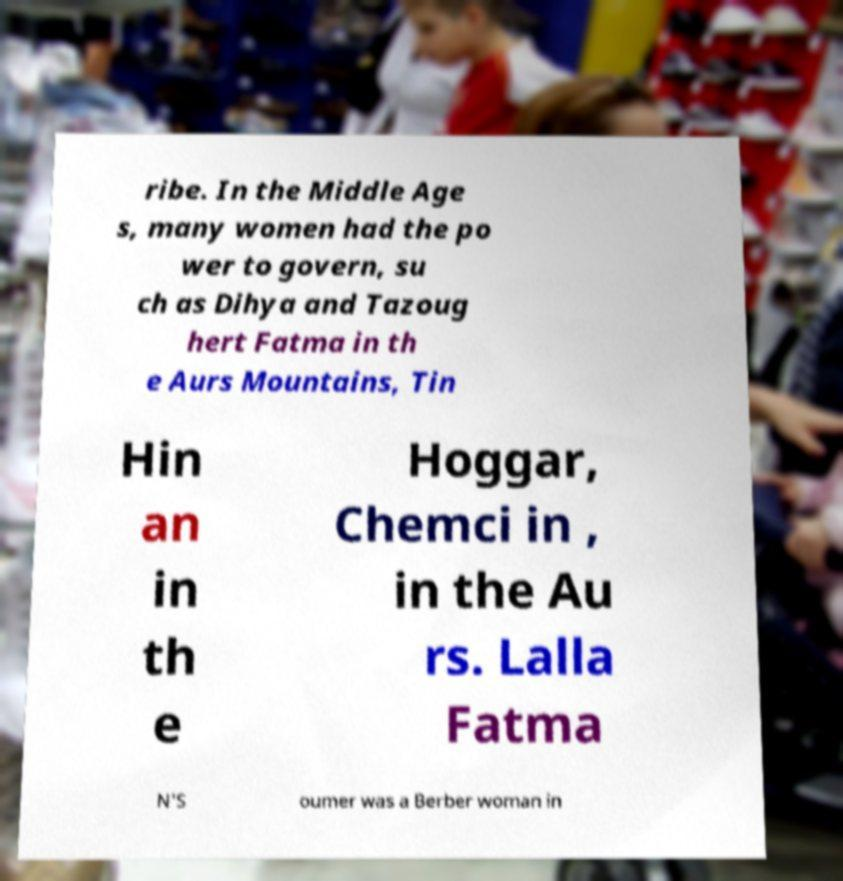What messages or text are displayed in this image? I need them in a readable, typed format. ribe. In the Middle Age s, many women had the po wer to govern, su ch as Dihya and Tazoug hert Fatma in th e Aurs Mountains, Tin Hin an in th e Hoggar, Chemci in , in the Au rs. Lalla Fatma N'S oumer was a Berber woman in 